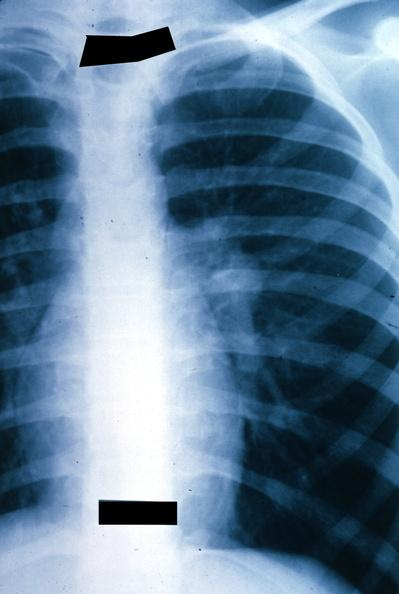what does this image show?
Answer the question using a single word or phrase. X-ray chest left hilar mass tumor in hilar node 